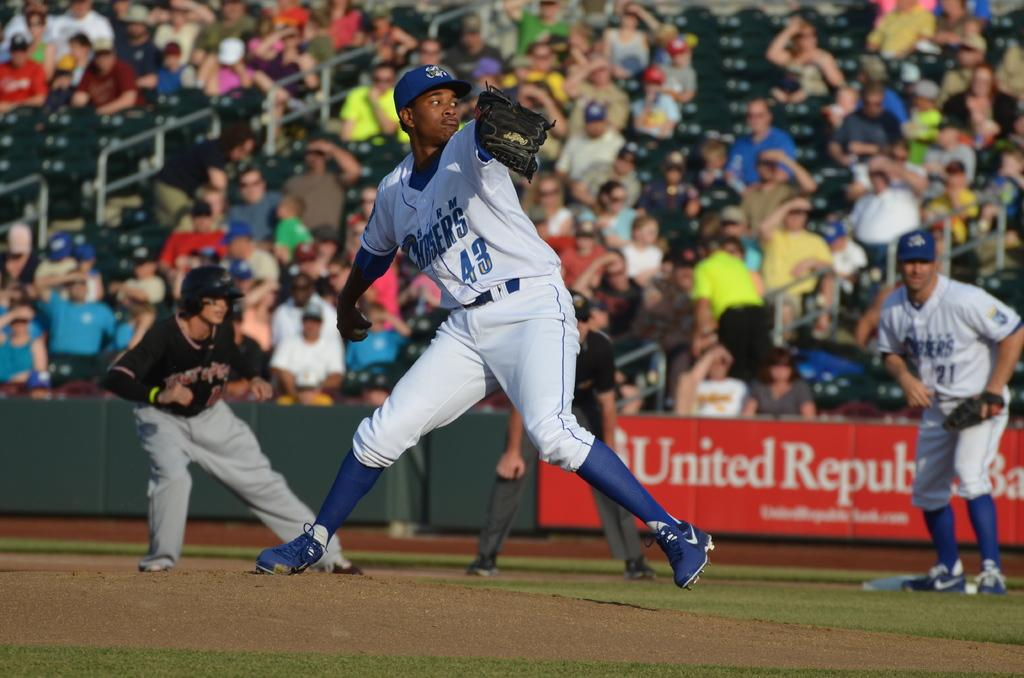Provide a one-sentence caption for the provided image. Number 43 of the Chargers is pitching on the mound in this game. 